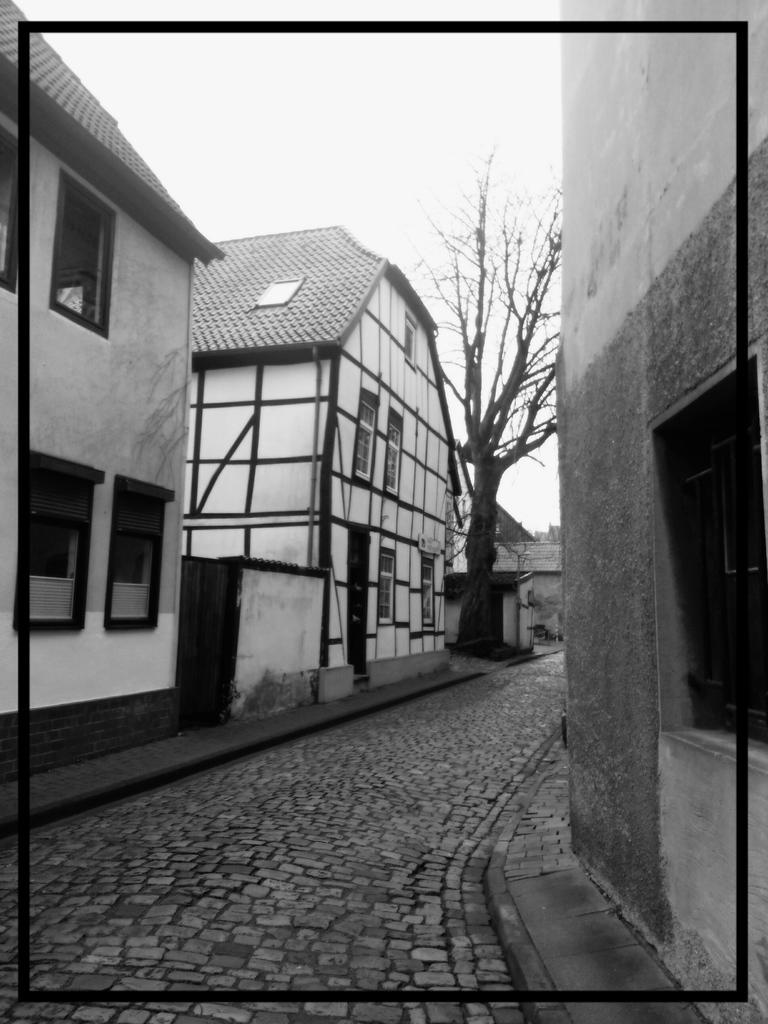What is the color scheme of the image? The image is black and white. What can be seen in the background of the image? There are houses and trees in the background of the image. What is located at the center of the image? There is a pavement at the center of the image. What is visible at the top of the image? The sky is visible at the top of the image. What type of science experiment is being conducted on the pavement in the image? There is no science experiment or any indication of one being conducted in the image. Can you see any sea creatures in the image? There is no sea or sea creatures present in the image. 